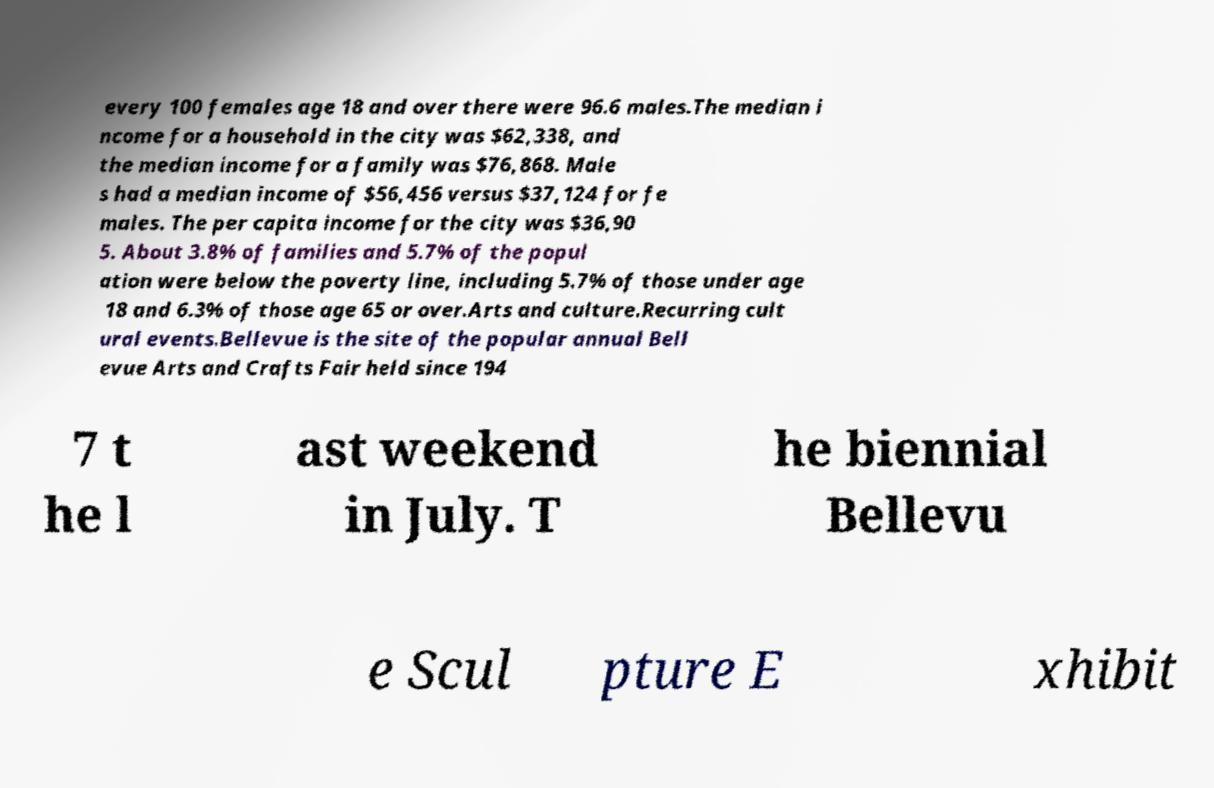I need the written content from this picture converted into text. Can you do that? every 100 females age 18 and over there were 96.6 males.The median i ncome for a household in the city was $62,338, and the median income for a family was $76,868. Male s had a median income of $56,456 versus $37,124 for fe males. The per capita income for the city was $36,90 5. About 3.8% of families and 5.7% of the popul ation were below the poverty line, including 5.7% of those under age 18 and 6.3% of those age 65 or over.Arts and culture.Recurring cult ural events.Bellevue is the site of the popular annual Bell evue Arts and Crafts Fair held since 194 7 t he l ast weekend in July. T he biennial Bellevu e Scul pture E xhibit 